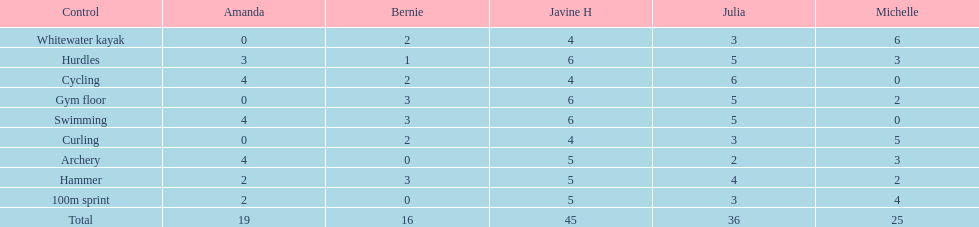What is the last discipline listed on this chart? 100m sprint. 